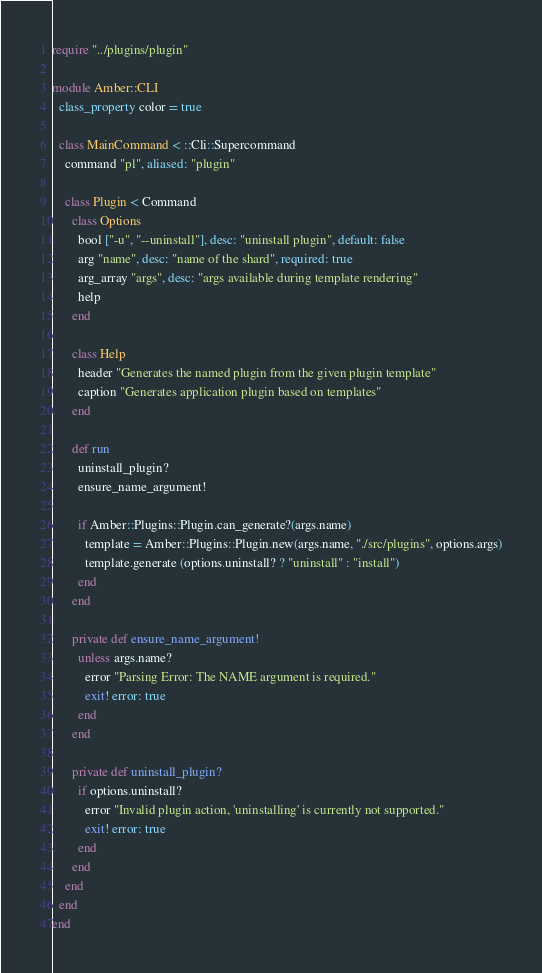<code> <loc_0><loc_0><loc_500><loc_500><_Crystal_>require "../plugins/plugin"

module Amber::CLI
  class_property color = true

  class MainCommand < ::Cli::Supercommand
    command "pl", aliased: "plugin"

    class Plugin < Command
      class Options
        bool ["-u", "--uninstall"], desc: "uninstall plugin", default: false
        arg "name", desc: "name of the shard", required: true
        arg_array "args", desc: "args available during template rendering"
        help
      end

      class Help
        header "Generates the named plugin from the given plugin template"
        caption "Generates application plugin based on templates"
      end

      def run
        uninstall_plugin?
        ensure_name_argument!

        if Amber::Plugins::Plugin.can_generate?(args.name)
          template = Amber::Plugins::Plugin.new(args.name, "./src/plugins", options.args)
          template.generate (options.uninstall? ? "uninstall" : "install")
        end
      end

      private def ensure_name_argument!
        unless args.name?
          error "Parsing Error: The NAME argument is required."
          exit! error: true
        end
      end

      private def uninstall_plugin?
        if options.uninstall?
          error "Invalid plugin action, 'uninstalling' is currently not supported."
          exit! error: true
        end
      end
    end
  end
end
</code> 